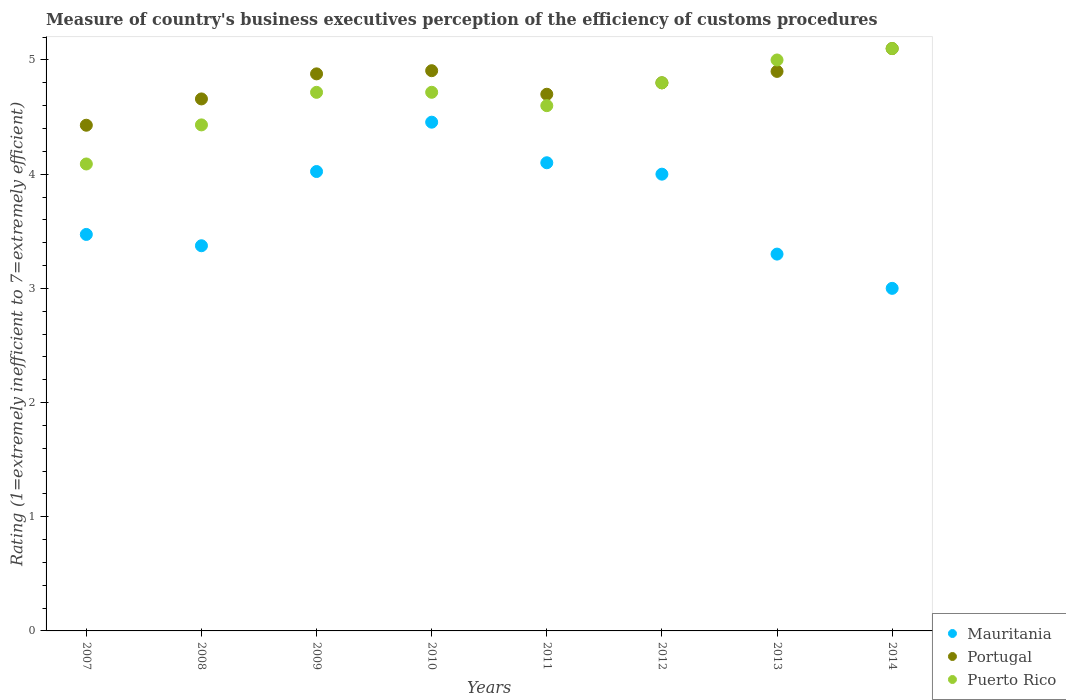How many different coloured dotlines are there?
Keep it short and to the point. 3. Across all years, what is the minimum rating of the efficiency of customs procedure in Mauritania?
Your response must be concise. 3. In which year was the rating of the efficiency of customs procedure in Mauritania minimum?
Your answer should be compact. 2014. What is the total rating of the efficiency of customs procedure in Portugal in the graph?
Provide a succinct answer. 38.37. What is the difference between the rating of the efficiency of customs procedure in Mauritania in 2008 and that in 2013?
Your answer should be very brief. 0.07. What is the difference between the rating of the efficiency of customs procedure in Portugal in 2010 and the rating of the efficiency of customs procedure in Mauritania in 2008?
Provide a succinct answer. 1.53. What is the average rating of the efficiency of customs procedure in Portugal per year?
Give a very brief answer. 4.8. In the year 2012, what is the difference between the rating of the efficiency of customs procedure in Puerto Rico and rating of the efficiency of customs procedure in Mauritania?
Offer a very short reply. 0.8. What is the ratio of the rating of the efficiency of customs procedure in Puerto Rico in 2007 to that in 2010?
Ensure brevity in your answer.  0.87. Is the difference between the rating of the efficiency of customs procedure in Puerto Rico in 2012 and 2013 greater than the difference between the rating of the efficiency of customs procedure in Mauritania in 2012 and 2013?
Provide a short and direct response. No. What is the difference between the highest and the second highest rating of the efficiency of customs procedure in Puerto Rico?
Offer a terse response. 0.1. What is the difference between the highest and the lowest rating of the efficiency of customs procedure in Mauritania?
Your answer should be very brief. 1.46. Is the sum of the rating of the efficiency of customs procedure in Portugal in 2008 and 2009 greater than the maximum rating of the efficiency of customs procedure in Puerto Rico across all years?
Keep it short and to the point. Yes. Is it the case that in every year, the sum of the rating of the efficiency of customs procedure in Portugal and rating of the efficiency of customs procedure in Puerto Rico  is greater than the rating of the efficiency of customs procedure in Mauritania?
Offer a terse response. Yes. Is the rating of the efficiency of customs procedure in Puerto Rico strictly less than the rating of the efficiency of customs procedure in Mauritania over the years?
Provide a short and direct response. No. How many dotlines are there?
Offer a very short reply. 3. What is the difference between two consecutive major ticks on the Y-axis?
Provide a short and direct response. 1. Are the values on the major ticks of Y-axis written in scientific E-notation?
Provide a succinct answer. No. How many legend labels are there?
Provide a succinct answer. 3. How are the legend labels stacked?
Provide a succinct answer. Vertical. What is the title of the graph?
Provide a succinct answer. Measure of country's business executives perception of the efficiency of customs procedures. What is the label or title of the Y-axis?
Keep it short and to the point. Rating (1=extremely inefficient to 7=extremely efficient). What is the Rating (1=extremely inefficient to 7=extremely efficient) of Mauritania in 2007?
Your answer should be very brief. 3.47. What is the Rating (1=extremely inefficient to 7=extremely efficient) in Portugal in 2007?
Offer a terse response. 4.43. What is the Rating (1=extremely inefficient to 7=extremely efficient) in Puerto Rico in 2007?
Provide a succinct answer. 4.09. What is the Rating (1=extremely inefficient to 7=extremely efficient) of Mauritania in 2008?
Give a very brief answer. 3.37. What is the Rating (1=extremely inefficient to 7=extremely efficient) of Portugal in 2008?
Give a very brief answer. 4.66. What is the Rating (1=extremely inefficient to 7=extremely efficient) in Puerto Rico in 2008?
Offer a very short reply. 4.43. What is the Rating (1=extremely inefficient to 7=extremely efficient) in Mauritania in 2009?
Your answer should be very brief. 4.02. What is the Rating (1=extremely inefficient to 7=extremely efficient) of Portugal in 2009?
Your response must be concise. 4.88. What is the Rating (1=extremely inefficient to 7=extremely efficient) in Puerto Rico in 2009?
Your response must be concise. 4.72. What is the Rating (1=extremely inefficient to 7=extremely efficient) in Mauritania in 2010?
Provide a succinct answer. 4.46. What is the Rating (1=extremely inefficient to 7=extremely efficient) in Portugal in 2010?
Give a very brief answer. 4.91. What is the Rating (1=extremely inefficient to 7=extremely efficient) in Puerto Rico in 2010?
Your response must be concise. 4.72. What is the Rating (1=extremely inefficient to 7=extremely efficient) in Puerto Rico in 2011?
Your response must be concise. 4.6. What is the Rating (1=extremely inefficient to 7=extremely efficient) of Portugal in 2012?
Ensure brevity in your answer.  4.8. What is the Rating (1=extremely inefficient to 7=extremely efficient) of Portugal in 2013?
Offer a terse response. 4.9. What is the Rating (1=extremely inefficient to 7=extremely efficient) of Mauritania in 2014?
Provide a succinct answer. 3. What is the Rating (1=extremely inefficient to 7=extremely efficient) of Portugal in 2014?
Your answer should be very brief. 5.1. What is the Rating (1=extremely inefficient to 7=extremely efficient) of Puerto Rico in 2014?
Make the answer very short. 5.1. Across all years, what is the maximum Rating (1=extremely inefficient to 7=extremely efficient) of Mauritania?
Ensure brevity in your answer.  4.46. Across all years, what is the maximum Rating (1=extremely inefficient to 7=extremely efficient) of Portugal?
Provide a short and direct response. 5.1. Across all years, what is the maximum Rating (1=extremely inefficient to 7=extremely efficient) of Puerto Rico?
Your response must be concise. 5.1. Across all years, what is the minimum Rating (1=extremely inefficient to 7=extremely efficient) in Mauritania?
Give a very brief answer. 3. Across all years, what is the minimum Rating (1=extremely inefficient to 7=extremely efficient) in Portugal?
Offer a terse response. 4.43. Across all years, what is the minimum Rating (1=extremely inefficient to 7=extremely efficient) of Puerto Rico?
Keep it short and to the point. 4.09. What is the total Rating (1=extremely inefficient to 7=extremely efficient) in Mauritania in the graph?
Make the answer very short. 29.72. What is the total Rating (1=extremely inefficient to 7=extremely efficient) in Portugal in the graph?
Give a very brief answer. 38.37. What is the total Rating (1=extremely inefficient to 7=extremely efficient) of Puerto Rico in the graph?
Offer a terse response. 37.45. What is the difference between the Rating (1=extremely inefficient to 7=extremely efficient) in Mauritania in 2007 and that in 2008?
Your answer should be compact. 0.1. What is the difference between the Rating (1=extremely inefficient to 7=extremely efficient) in Portugal in 2007 and that in 2008?
Ensure brevity in your answer.  -0.23. What is the difference between the Rating (1=extremely inefficient to 7=extremely efficient) of Puerto Rico in 2007 and that in 2008?
Offer a terse response. -0.34. What is the difference between the Rating (1=extremely inefficient to 7=extremely efficient) in Mauritania in 2007 and that in 2009?
Give a very brief answer. -0.55. What is the difference between the Rating (1=extremely inefficient to 7=extremely efficient) in Portugal in 2007 and that in 2009?
Offer a terse response. -0.45. What is the difference between the Rating (1=extremely inefficient to 7=extremely efficient) in Puerto Rico in 2007 and that in 2009?
Offer a very short reply. -0.63. What is the difference between the Rating (1=extremely inefficient to 7=extremely efficient) in Mauritania in 2007 and that in 2010?
Your response must be concise. -0.98. What is the difference between the Rating (1=extremely inefficient to 7=extremely efficient) of Portugal in 2007 and that in 2010?
Ensure brevity in your answer.  -0.48. What is the difference between the Rating (1=extremely inefficient to 7=extremely efficient) in Puerto Rico in 2007 and that in 2010?
Your answer should be very brief. -0.63. What is the difference between the Rating (1=extremely inefficient to 7=extremely efficient) of Mauritania in 2007 and that in 2011?
Make the answer very short. -0.63. What is the difference between the Rating (1=extremely inefficient to 7=extremely efficient) of Portugal in 2007 and that in 2011?
Provide a short and direct response. -0.27. What is the difference between the Rating (1=extremely inefficient to 7=extremely efficient) of Puerto Rico in 2007 and that in 2011?
Provide a short and direct response. -0.51. What is the difference between the Rating (1=extremely inefficient to 7=extremely efficient) in Mauritania in 2007 and that in 2012?
Your response must be concise. -0.53. What is the difference between the Rating (1=extremely inefficient to 7=extremely efficient) in Portugal in 2007 and that in 2012?
Your response must be concise. -0.37. What is the difference between the Rating (1=extremely inefficient to 7=extremely efficient) in Puerto Rico in 2007 and that in 2012?
Make the answer very short. -0.71. What is the difference between the Rating (1=extremely inefficient to 7=extremely efficient) of Mauritania in 2007 and that in 2013?
Your answer should be compact. 0.17. What is the difference between the Rating (1=extremely inefficient to 7=extremely efficient) of Portugal in 2007 and that in 2013?
Ensure brevity in your answer.  -0.47. What is the difference between the Rating (1=extremely inefficient to 7=extremely efficient) of Puerto Rico in 2007 and that in 2013?
Offer a terse response. -0.91. What is the difference between the Rating (1=extremely inefficient to 7=extremely efficient) of Mauritania in 2007 and that in 2014?
Offer a terse response. 0.47. What is the difference between the Rating (1=extremely inefficient to 7=extremely efficient) of Portugal in 2007 and that in 2014?
Offer a very short reply. -0.67. What is the difference between the Rating (1=extremely inefficient to 7=extremely efficient) of Puerto Rico in 2007 and that in 2014?
Provide a short and direct response. -1.01. What is the difference between the Rating (1=extremely inefficient to 7=extremely efficient) of Mauritania in 2008 and that in 2009?
Your answer should be compact. -0.65. What is the difference between the Rating (1=extremely inefficient to 7=extremely efficient) in Portugal in 2008 and that in 2009?
Offer a very short reply. -0.22. What is the difference between the Rating (1=extremely inefficient to 7=extremely efficient) of Puerto Rico in 2008 and that in 2009?
Give a very brief answer. -0.29. What is the difference between the Rating (1=extremely inefficient to 7=extremely efficient) in Mauritania in 2008 and that in 2010?
Keep it short and to the point. -1.08. What is the difference between the Rating (1=extremely inefficient to 7=extremely efficient) in Portugal in 2008 and that in 2010?
Give a very brief answer. -0.25. What is the difference between the Rating (1=extremely inefficient to 7=extremely efficient) of Puerto Rico in 2008 and that in 2010?
Keep it short and to the point. -0.29. What is the difference between the Rating (1=extremely inefficient to 7=extremely efficient) of Mauritania in 2008 and that in 2011?
Keep it short and to the point. -0.73. What is the difference between the Rating (1=extremely inefficient to 7=extremely efficient) in Portugal in 2008 and that in 2011?
Provide a succinct answer. -0.04. What is the difference between the Rating (1=extremely inefficient to 7=extremely efficient) in Puerto Rico in 2008 and that in 2011?
Ensure brevity in your answer.  -0.17. What is the difference between the Rating (1=extremely inefficient to 7=extremely efficient) of Mauritania in 2008 and that in 2012?
Provide a succinct answer. -0.63. What is the difference between the Rating (1=extremely inefficient to 7=extremely efficient) in Portugal in 2008 and that in 2012?
Give a very brief answer. -0.14. What is the difference between the Rating (1=extremely inefficient to 7=extremely efficient) of Puerto Rico in 2008 and that in 2012?
Offer a terse response. -0.37. What is the difference between the Rating (1=extremely inefficient to 7=extremely efficient) in Mauritania in 2008 and that in 2013?
Offer a very short reply. 0.07. What is the difference between the Rating (1=extremely inefficient to 7=extremely efficient) in Portugal in 2008 and that in 2013?
Your answer should be very brief. -0.24. What is the difference between the Rating (1=extremely inefficient to 7=extremely efficient) in Puerto Rico in 2008 and that in 2013?
Your response must be concise. -0.57. What is the difference between the Rating (1=extremely inefficient to 7=extremely efficient) in Mauritania in 2008 and that in 2014?
Give a very brief answer. 0.37. What is the difference between the Rating (1=extremely inefficient to 7=extremely efficient) in Portugal in 2008 and that in 2014?
Provide a short and direct response. -0.44. What is the difference between the Rating (1=extremely inefficient to 7=extremely efficient) in Puerto Rico in 2008 and that in 2014?
Provide a succinct answer. -0.67. What is the difference between the Rating (1=extremely inefficient to 7=extremely efficient) of Mauritania in 2009 and that in 2010?
Offer a very short reply. -0.43. What is the difference between the Rating (1=extremely inefficient to 7=extremely efficient) in Portugal in 2009 and that in 2010?
Offer a very short reply. -0.03. What is the difference between the Rating (1=extremely inefficient to 7=extremely efficient) in Puerto Rico in 2009 and that in 2010?
Make the answer very short. -0. What is the difference between the Rating (1=extremely inefficient to 7=extremely efficient) of Mauritania in 2009 and that in 2011?
Provide a succinct answer. -0.08. What is the difference between the Rating (1=extremely inefficient to 7=extremely efficient) of Portugal in 2009 and that in 2011?
Your answer should be compact. 0.18. What is the difference between the Rating (1=extremely inefficient to 7=extremely efficient) of Puerto Rico in 2009 and that in 2011?
Keep it short and to the point. 0.12. What is the difference between the Rating (1=extremely inefficient to 7=extremely efficient) in Mauritania in 2009 and that in 2012?
Offer a very short reply. 0.02. What is the difference between the Rating (1=extremely inefficient to 7=extremely efficient) in Portugal in 2009 and that in 2012?
Your answer should be compact. 0.08. What is the difference between the Rating (1=extremely inefficient to 7=extremely efficient) in Puerto Rico in 2009 and that in 2012?
Your response must be concise. -0.08. What is the difference between the Rating (1=extremely inefficient to 7=extremely efficient) in Mauritania in 2009 and that in 2013?
Keep it short and to the point. 0.72. What is the difference between the Rating (1=extremely inefficient to 7=extremely efficient) in Portugal in 2009 and that in 2013?
Your response must be concise. -0.02. What is the difference between the Rating (1=extremely inefficient to 7=extremely efficient) of Puerto Rico in 2009 and that in 2013?
Your answer should be compact. -0.28. What is the difference between the Rating (1=extremely inefficient to 7=extremely efficient) in Mauritania in 2009 and that in 2014?
Provide a short and direct response. 1.02. What is the difference between the Rating (1=extremely inefficient to 7=extremely efficient) of Portugal in 2009 and that in 2014?
Make the answer very short. -0.22. What is the difference between the Rating (1=extremely inefficient to 7=extremely efficient) in Puerto Rico in 2009 and that in 2014?
Keep it short and to the point. -0.38. What is the difference between the Rating (1=extremely inefficient to 7=extremely efficient) in Mauritania in 2010 and that in 2011?
Provide a succinct answer. 0.36. What is the difference between the Rating (1=extremely inefficient to 7=extremely efficient) in Portugal in 2010 and that in 2011?
Your answer should be very brief. 0.21. What is the difference between the Rating (1=extremely inefficient to 7=extremely efficient) of Puerto Rico in 2010 and that in 2011?
Offer a terse response. 0.12. What is the difference between the Rating (1=extremely inefficient to 7=extremely efficient) of Mauritania in 2010 and that in 2012?
Provide a succinct answer. 0.46. What is the difference between the Rating (1=extremely inefficient to 7=extremely efficient) in Portugal in 2010 and that in 2012?
Provide a succinct answer. 0.11. What is the difference between the Rating (1=extremely inefficient to 7=extremely efficient) in Puerto Rico in 2010 and that in 2012?
Offer a very short reply. -0.08. What is the difference between the Rating (1=extremely inefficient to 7=extremely efficient) in Mauritania in 2010 and that in 2013?
Your answer should be very brief. 1.16. What is the difference between the Rating (1=extremely inefficient to 7=extremely efficient) of Portugal in 2010 and that in 2013?
Your answer should be very brief. 0.01. What is the difference between the Rating (1=extremely inefficient to 7=extremely efficient) in Puerto Rico in 2010 and that in 2013?
Your answer should be compact. -0.28. What is the difference between the Rating (1=extremely inefficient to 7=extremely efficient) in Mauritania in 2010 and that in 2014?
Give a very brief answer. 1.46. What is the difference between the Rating (1=extremely inefficient to 7=extremely efficient) of Portugal in 2010 and that in 2014?
Ensure brevity in your answer.  -0.19. What is the difference between the Rating (1=extremely inefficient to 7=extremely efficient) of Puerto Rico in 2010 and that in 2014?
Ensure brevity in your answer.  -0.38. What is the difference between the Rating (1=extremely inefficient to 7=extremely efficient) in Mauritania in 2011 and that in 2012?
Your answer should be compact. 0.1. What is the difference between the Rating (1=extremely inefficient to 7=extremely efficient) in Portugal in 2011 and that in 2012?
Your answer should be compact. -0.1. What is the difference between the Rating (1=extremely inefficient to 7=extremely efficient) in Mauritania in 2011 and that in 2013?
Provide a short and direct response. 0.8. What is the difference between the Rating (1=extremely inefficient to 7=extremely efficient) of Mauritania in 2011 and that in 2014?
Keep it short and to the point. 1.1. What is the difference between the Rating (1=extremely inefficient to 7=extremely efficient) in Portugal in 2012 and that in 2013?
Give a very brief answer. -0.1. What is the difference between the Rating (1=extremely inefficient to 7=extremely efficient) in Puerto Rico in 2012 and that in 2013?
Offer a very short reply. -0.2. What is the difference between the Rating (1=extremely inefficient to 7=extremely efficient) in Mauritania in 2013 and that in 2014?
Ensure brevity in your answer.  0.3. What is the difference between the Rating (1=extremely inefficient to 7=extremely efficient) of Portugal in 2013 and that in 2014?
Your answer should be very brief. -0.2. What is the difference between the Rating (1=extremely inefficient to 7=extremely efficient) in Mauritania in 2007 and the Rating (1=extremely inefficient to 7=extremely efficient) in Portugal in 2008?
Give a very brief answer. -1.19. What is the difference between the Rating (1=extremely inefficient to 7=extremely efficient) of Mauritania in 2007 and the Rating (1=extremely inefficient to 7=extremely efficient) of Puerto Rico in 2008?
Your answer should be compact. -0.96. What is the difference between the Rating (1=extremely inefficient to 7=extremely efficient) in Portugal in 2007 and the Rating (1=extremely inefficient to 7=extremely efficient) in Puerto Rico in 2008?
Make the answer very short. -0. What is the difference between the Rating (1=extremely inefficient to 7=extremely efficient) in Mauritania in 2007 and the Rating (1=extremely inefficient to 7=extremely efficient) in Portugal in 2009?
Offer a very short reply. -1.41. What is the difference between the Rating (1=extremely inefficient to 7=extremely efficient) in Mauritania in 2007 and the Rating (1=extremely inefficient to 7=extremely efficient) in Puerto Rico in 2009?
Your answer should be compact. -1.24. What is the difference between the Rating (1=extremely inefficient to 7=extremely efficient) of Portugal in 2007 and the Rating (1=extremely inefficient to 7=extremely efficient) of Puerto Rico in 2009?
Make the answer very short. -0.29. What is the difference between the Rating (1=extremely inefficient to 7=extremely efficient) in Mauritania in 2007 and the Rating (1=extremely inefficient to 7=extremely efficient) in Portugal in 2010?
Make the answer very short. -1.43. What is the difference between the Rating (1=extremely inefficient to 7=extremely efficient) in Mauritania in 2007 and the Rating (1=extremely inefficient to 7=extremely efficient) in Puerto Rico in 2010?
Your response must be concise. -1.24. What is the difference between the Rating (1=extremely inefficient to 7=extremely efficient) of Portugal in 2007 and the Rating (1=extremely inefficient to 7=extremely efficient) of Puerto Rico in 2010?
Your response must be concise. -0.29. What is the difference between the Rating (1=extremely inefficient to 7=extremely efficient) of Mauritania in 2007 and the Rating (1=extremely inefficient to 7=extremely efficient) of Portugal in 2011?
Your answer should be compact. -1.23. What is the difference between the Rating (1=extremely inefficient to 7=extremely efficient) of Mauritania in 2007 and the Rating (1=extremely inefficient to 7=extremely efficient) of Puerto Rico in 2011?
Keep it short and to the point. -1.13. What is the difference between the Rating (1=extremely inefficient to 7=extremely efficient) in Portugal in 2007 and the Rating (1=extremely inefficient to 7=extremely efficient) in Puerto Rico in 2011?
Offer a terse response. -0.17. What is the difference between the Rating (1=extremely inefficient to 7=extremely efficient) in Mauritania in 2007 and the Rating (1=extremely inefficient to 7=extremely efficient) in Portugal in 2012?
Offer a very short reply. -1.33. What is the difference between the Rating (1=extremely inefficient to 7=extremely efficient) of Mauritania in 2007 and the Rating (1=extremely inefficient to 7=extremely efficient) of Puerto Rico in 2012?
Keep it short and to the point. -1.33. What is the difference between the Rating (1=extremely inefficient to 7=extremely efficient) in Portugal in 2007 and the Rating (1=extremely inefficient to 7=extremely efficient) in Puerto Rico in 2012?
Offer a terse response. -0.37. What is the difference between the Rating (1=extremely inefficient to 7=extremely efficient) of Mauritania in 2007 and the Rating (1=extremely inefficient to 7=extremely efficient) of Portugal in 2013?
Your answer should be compact. -1.43. What is the difference between the Rating (1=extremely inefficient to 7=extremely efficient) of Mauritania in 2007 and the Rating (1=extremely inefficient to 7=extremely efficient) of Puerto Rico in 2013?
Give a very brief answer. -1.53. What is the difference between the Rating (1=extremely inefficient to 7=extremely efficient) of Portugal in 2007 and the Rating (1=extremely inefficient to 7=extremely efficient) of Puerto Rico in 2013?
Your response must be concise. -0.57. What is the difference between the Rating (1=extremely inefficient to 7=extremely efficient) in Mauritania in 2007 and the Rating (1=extremely inefficient to 7=extremely efficient) in Portugal in 2014?
Offer a very short reply. -1.63. What is the difference between the Rating (1=extremely inefficient to 7=extremely efficient) of Mauritania in 2007 and the Rating (1=extremely inefficient to 7=extremely efficient) of Puerto Rico in 2014?
Provide a succinct answer. -1.63. What is the difference between the Rating (1=extremely inefficient to 7=extremely efficient) in Portugal in 2007 and the Rating (1=extremely inefficient to 7=extremely efficient) in Puerto Rico in 2014?
Offer a very short reply. -0.67. What is the difference between the Rating (1=extremely inefficient to 7=extremely efficient) of Mauritania in 2008 and the Rating (1=extremely inefficient to 7=extremely efficient) of Portugal in 2009?
Offer a terse response. -1.51. What is the difference between the Rating (1=extremely inefficient to 7=extremely efficient) in Mauritania in 2008 and the Rating (1=extremely inefficient to 7=extremely efficient) in Puerto Rico in 2009?
Ensure brevity in your answer.  -1.34. What is the difference between the Rating (1=extremely inefficient to 7=extremely efficient) of Portugal in 2008 and the Rating (1=extremely inefficient to 7=extremely efficient) of Puerto Rico in 2009?
Offer a terse response. -0.06. What is the difference between the Rating (1=extremely inefficient to 7=extremely efficient) in Mauritania in 2008 and the Rating (1=extremely inefficient to 7=extremely efficient) in Portugal in 2010?
Ensure brevity in your answer.  -1.53. What is the difference between the Rating (1=extremely inefficient to 7=extremely efficient) in Mauritania in 2008 and the Rating (1=extremely inefficient to 7=extremely efficient) in Puerto Rico in 2010?
Ensure brevity in your answer.  -1.34. What is the difference between the Rating (1=extremely inefficient to 7=extremely efficient) in Portugal in 2008 and the Rating (1=extremely inefficient to 7=extremely efficient) in Puerto Rico in 2010?
Your response must be concise. -0.06. What is the difference between the Rating (1=extremely inefficient to 7=extremely efficient) of Mauritania in 2008 and the Rating (1=extremely inefficient to 7=extremely efficient) of Portugal in 2011?
Give a very brief answer. -1.33. What is the difference between the Rating (1=extremely inefficient to 7=extremely efficient) in Mauritania in 2008 and the Rating (1=extremely inefficient to 7=extremely efficient) in Puerto Rico in 2011?
Make the answer very short. -1.23. What is the difference between the Rating (1=extremely inefficient to 7=extremely efficient) in Portugal in 2008 and the Rating (1=extremely inefficient to 7=extremely efficient) in Puerto Rico in 2011?
Provide a succinct answer. 0.06. What is the difference between the Rating (1=extremely inefficient to 7=extremely efficient) in Mauritania in 2008 and the Rating (1=extremely inefficient to 7=extremely efficient) in Portugal in 2012?
Offer a terse response. -1.43. What is the difference between the Rating (1=extremely inefficient to 7=extremely efficient) in Mauritania in 2008 and the Rating (1=extremely inefficient to 7=extremely efficient) in Puerto Rico in 2012?
Make the answer very short. -1.43. What is the difference between the Rating (1=extremely inefficient to 7=extremely efficient) of Portugal in 2008 and the Rating (1=extremely inefficient to 7=extremely efficient) of Puerto Rico in 2012?
Provide a succinct answer. -0.14. What is the difference between the Rating (1=extremely inefficient to 7=extremely efficient) in Mauritania in 2008 and the Rating (1=extremely inefficient to 7=extremely efficient) in Portugal in 2013?
Offer a terse response. -1.53. What is the difference between the Rating (1=extremely inefficient to 7=extremely efficient) of Mauritania in 2008 and the Rating (1=extremely inefficient to 7=extremely efficient) of Puerto Rico in 2013?
Make the answer very short. -1.63. What is the difference between the Rating (1=extremely inefficient to 7=extremely efficient) in Portugal in 2008 and the Rating (1=extremely inefficient to 7=extremely efficient) in Puerto Rico in 2013?
Your answer should be compact. -0.34. What is the difference between the Rating (1=extremely inefficient to 7=extremely efficient) in Mauritania in 2008 and the Rating (1=extremely inefficient to 7=extremely efficient) in Portugal in 2014?
Offer a very short reply. -1.73. What is the difference between the Rating (1=extremely inefficient to 7=extremely efficient) in Mauritania in 2008 and the Rating (1=extremely inefficient to 7=extremely efficient) in Puerto Rico in 2014?
Your answer should be compact. -1.73. What is the difference between the Rating (1=extremely inefficient to 7=extremely efficient) in Portugal in 2008 and the Rating (1=extremely inefficient to 7=extremely efficient) in Puerto Rico in 2014?
Make the answer very short. -0.44. What is the difference between the Rating (1=extremely inefficient to 7=extremely efficient) of Mauritania in 2009 and the Rating (1=extremely inefficient to 7=extremely efficient) of Portugal in 2010?
Offer a terse response. -0.88. What is the difference between the Rating (1=extremely inefficient to 7=extremely efficient) of Mauritania in 2009 and the Rating (1=extremely inefficient to 7=extremely efficient) of Puerto Rico in 2010?
Offer a terse response. -0.69. What is the difference between the Rating (1=extremely inefficient to 7=extremely efficient) in Portugal in 2009 and the Rating (1=extremely inefficient to 7=extremely efficient) in Puerto Rico in 2010?
Offer a terse response. 0.16. What is the difference between the Rating (1=extremely inefficient to 7=extremely efficient) of Mauritania in 2009 and the Rating (1=extremely inefficient to 7=extremely efficient) of Portugal in 2011?
Provide a succinct answer. -0.68. What is the difference between the Rating (1=extremely inefficient to 7=extremely efficient) in Mauritania in 2009 and the Rating (1=extremely inefficient to 7=extremely efficient) in Puerto Rico in 2011?
Provide a short and direct response. -0.58. What is the difference between the Rating (1=extremely inefficient to 7=extremely efficient) of Portugal in 2009 and the Rating (1=extremely inefficient to 7=extremely efficient) of Puerto Rico in 2011?
Provide a succinct answer. 0.28. What is the difference between the Rating (1=extremely inefficient to 7=extremely efficient) of Mauritania in 2009 and the Rating (1=extremely inefficient to 7=extremely efficient) of Portugal in 2012?
Offer a very short reply. -0.78. What is the difference between the Rating (1=extremely inefficient to 7=extremely efficient) in Mauritania in 2009 and the Rating (1=extremely inefficient to 7=extremely efficient) in Puerto Rico in 2012?
Ensure brevity in your answer.  -0.78. What is the difference between the Rating (1=extremely inefficient to 7=extremely efficient) in Portugal in 2009 and the Rating (1=extremely inefficient to 7=extremely efficient) in Puerto Rico in 2012?
Keep it short and to the point. 0.08. What is the difference between the Rating (1=extremely inefficient to 7=extremely efficient) in Mauritania in 2009 and the Rating (1=extremely inefficient to 7=extremely efficient) in Portugal in 2013?
Keep it short and to the point. -0.88. What is the difference between the Rating (1=extremely inefficient to 7=extremely efficient) in Mauritania in 2009 and the Rating (1=extremely inefficient to 7=extremely efficient) in Puerto Rico in 2013?
Your answer should be very brief. -0.98. What is the difference between the Rating (1=extremely inefficient to 7=extremely efficient) in Portugal in 2009 and the Rating (1=extremely inefficient to 7=extremely efficient) in Puerto Rico in 2013?
Your answer should be very brief. -0.12. What is the difference between the Rating (1=extremely inefficient to 7=extremely efficient) of Mauritania in 2009 and the Rating (1=extremely inefficient to 7=extremely efficient) of Portugal in 2014?
Offer a terse response. -1.08. What is the difference between the Rating (1=extremely inefficient to 7=extremely efficient) in Mauritania in 2009 and the Rating (1=extremely inefficient to 7=extremely efficient) in Puerto Rico in 2014?
Your answer should be very brief. -1.08. What is the difference between the Rating (1=extremely inefficient to 7=extremely efficient) of Portugal in 2009 and the Rating (1=extremely inefficient to 7=extremely efficient) of Puerto Rico in 2014?
Offer a terse response. -0.22. What is the difference between the Rating (1=extremely inefficient to 7=extremely efficient) in Mauritania in 2010 and the Rating (1=extremely inefficient to 7=extremely efficient) in Portugal in 2011?
Give a very brief answer. -0.24. What is the difference between the Rating (1=extremely inefficient to 7=extremely efficient) in Mauritania in 2010 and the Rating (1=extremely inefficient to 7=extremely efficient) in Puerto Rico in 2011?
Ensure brevity in your answer.  -0.14. What is the difference between the Rating (1=extremely inefficient to 7=extremely efficient) of Portugal in 2010 and the Rating (1=extremely inefficient to 7=extremely efficient) of Puerto Rico in 2011?
Provide a succinct answer. 0.31. What is the difference between the Rating (1=extremely inefficient to 7=extremely efficient) in Mauritania in 2010 and the Rating (1=extremely inefficient to 7=extremely efficient) in Portugal in 2012?
Ensure brevity in your answer.  -0.34. What is the difference between the Rating (1=extremely inefficient to 7=extremely efficient) in Mauritania in 2010 and the Rating (1=extremely inefficient to 7=extremely efficient) in Puerto Rico in 2012?
Your answer should be very brief. -0.34. What is the difference between the Rating (1=extremely inefficient to 7=extremely efficient) in Portugal in 2010 and the Rating (1=extremely inefficient to 7=extremely efficient) in Puerto Rico in 2012?
Your response must be concise. 0.11. What is the difference between the Rating (1=extremely inefficient to 7=extremely efficient) in Mauritania in 2010 and the Rating (1=extremely inefficient to 7=extremely efficient) in Portugal in 2013?
Your response must be concise. -0.44. What is the difference between the Rating (1=extremely inefficient to 7=extremely efficient) of Mauritania in 2010 and the Rating (1=extremely inefficient to 7=extremely efficient) of Puerto Rico in 2013?
Ensure brevity in your answer.  -0.54. What is the difference between the Rating (1=extremely inefficient to 7=extremely efficient) of Portugal in 2010 and the Rating (1=extremely inefficient to 7=extremely efficient) of Puerto Rico in 2013?
Your answer should be very brief. -0.09. What is the difference between the Rating (1=extremely inefficient to 7=extremely efficient) in Mauritania in 2010 and the Rating (1=extremely inefficient to 7=extremely efficient) in Portugal in 2014?
Your answer should be very brief. -0.64. What is the difference between the Rating (1=extremely inefficient to 7=extremely efficient) of Mauritania in 2010 and the Rating (1=extremely inefficient to 7=extremely efficient) of Puerto Rico in 2014?
Offer a terse response. -0.64. What is the difference between the Rating (1=extremely inefficient to 7=extremely efficient) of Portugal in 2010 and the Rating (1=extremely inefficient to 7=extremely efficient) of Puerto Rico in 2014?
Make the answer very short. -0.19. What is the difference between the Rating (1=extremely inefficient to 7=extremely efficient) in Portugal in 2011 and the Rating (1=extremely inefficient to 7=extremely efficient) in Puerto Rico in 2012?
Ensure brevity in your answer.  -0.1. What is the difference between the Rating (1=extremely inefficient to 7=extremely efficient) in Mauritania in 2012 and the Rating (1=extremely inefficient to 7=extremely efficient) in Portugal in 2014?
Your answer should be compact. -1.1. What is the difference between the Rating (1=extremely inefficient to 7=extremely efficient) of Mauritania in 2012 and the Rating (1=extremely inefficient to 7=extremely efficient) of Puerto Rico in 2014?
Ensure brevity in your answer.  -1.1. What is the difference between the Rating (1=extremely inefficient to 7=extremely efficient) of Portugal in 2012 and the Rating (1=extremely inefficient to 7=extremely efficient) of Puerto Rico in 2014?
Offer a terse response. -0.3. What is the average Rating (1=extremely inefficient to 7=extremely efficient) of Mauritania per year?
Your response must be concise. 3.72. What is the average Rating (1=extremely inefficient to 7=extremely efficient) of Portugal per year?
Make the answer very short. 4.8. What is the average Rating (1=extremely inefficient to 7=extremely efficient) in Puerto Rico per year?
Your answer should be very brief. 4.68. In the year 2007, what is the difference between the Rating (1=extremely inefficient to 7=extremely efficient) of Mauritania and Rating (1=extremely inefficient to 7=extremely efficient) of Portugal?
Offer a very short reply. -0.96. In the year 2007, what is the difference between the Rating (1=extremely inefficient to 7=extremely efficient) of Mauritania and Rating (1=extremely inefficient to 7=extremely efficient) of Puerto Rico?
Give a very brief answer. -0.62. In the year 2007, what is the difference between the Rating (1=extremely inefficient to 7=extremely efficient) in Portugal and Rating (1=extremely inefficient to 7=extremely efficient) in Puerto Rico?
Your answer should be very brief. 0.34. In the year 2008, what is the difference between the Rating (1=extremely inefficient to 7=extremely efficient) in Mauritania and Rating (1=extremely inefficient to 7=extremely efficient) in Portugal?
Provide a short and direct response. -1.29. In the year 2008, what is the difference between the Rating (1=extremely inefficient to 7=extremely efficient) of Mauritania and Rating (1=extremely inefficient to 7=extremely efficient) of Puerto Rico?
Your answer should be very brief. -1.06. In the year 2008, what is the difference between the Rating (1=extremely inefficient to 7=extremely efficient) of Portugal and Rating (1=extremely inefficient to 7=extremely efficient) of Puerto Rico?
Provide a succinct answer. 0.23. In the year 2009, what is the difference between the Rating (1=extremely inefficient to 7=extremely efficient) in Mauritania and Rating (1=extremely inefficient to 7=extremely efficient) in Portugal?
Give a very brief answer. -0.86. In the year 2009, what is the difference between the Rating (1=extremely inefficient to 7=extremely efficient) of Mauritania and Rating (1=extremely inefficient to 7=extremely efficient) of Puerto Rico?
Provide a succinct answer. -0.69. In the year 2009, what is the difference between the Rating (1=extremely inefficient to 7=extremely efficient) in Portugal and Rating (1=extremely inefficient to 7=extremely efficient) in Puerto Rico?
Your answer should be very brief. 0.16. In the year 2010, what is the difference between the Rating (1=extremely inefficient to 7=extremely efficient) in Mauritania and Rating (1=extremely inefficient to 7=extremely efficient) in Portugal?
Provide a short and direct response. -0.45. In the year 2010, what is the difference between the Rating (1=extremely inefficient to 7=extremely efficient) in Mauritania and Rating (1=extremely inefficient to 7=extremely efficient) in Puerto Rico?
Offer a terse response. -0.26. In the year 2010, what is the difference between the Rating (1=extremely inefficient to 7=extremely efficient) in Portugal and Rating (1=extremely inefficient to 7=extremely efficient) in Puerto Rico?
Make the answer very short. 0.19. In the year 2012, what is the difference between the Rating (1=extremely inefficient to 7=extremely efficient) in Mauritania and Rating (1=extremely inefficient to 7=extremely efficient) in Portugal?
Keep it short and to the point. -0.8. In the year 2014, what is the difference between the Rating (1=extremely inefficient to 7=extremely efficient) of Mauritania and Rating (1=extremely inefficient to 7=extremely efficient) of Portugal?
Offer a terse response. -2.1. In the year 2014, what is the difference between the Rating (1=extremely inefficient to 7=extremely efficient) in Mauritania and Rating (1=extremely inefficient to 7=extremely efficient) in Puerto Rico?
Give a very brief answer. -2.1. In the year 2014, what is the difference between the Rating (1=extremely inefficient to 7=extremely efficient) of Portugal and Rating (1=extremely inefficient to 7=extremely efficient) of Puerto Rico?
Your answer should be very brief. 0. What is the ratio of the Rating (1=extremely inefficient to 7=extremely efficient) of Mauritania in 2007 to that in 2008?
Make the answer very short. 1.03. What is the ratio of the Rating (1=extremely inefficient to 7=extremely efficient) of Portugal in 2007 to that in 2008?
Your answer should be compact. 0.95. What is the ratio of the Rating (1=extremely inefficient to 7=extremely efficient) of Puerto Rico in 2007 to that in 2008?
Provide a succinct answer. 0.92. What is the ratio of the Rating (1=extremely inefficient to 7=extremely efficient) in Mauritania in 2007 to that in 2009?
Ensure brevity in your answer.  0.86. What is the ratio of the Rating (1=extremely inefficient to 7=extremely efficient) in Portugal in 2007 to that in 2009?
Provide a succinct answer. 0.91. What is the ratio of the Rating (1=extremely inefficient to 7=extremely efficient) of Puerto Rico in 2007 to that in 2009?
Ensure brevity in your answer.  0.87. What is the ratio of the Rating (1=extremely inefficient to 7=extremely efficient) of Mauritania in 2007 to that in 2010?
Ensure brevity in your answer.  0.78. What is the ratio of the Rating (1=extremely inefficient to 7=extremely efficient) in Portugal in 2007 to that in 2010?
Give a very brief answer. 0.9. What is the ratio of the Rating (1=extremely inefficient to 7=extremely efficient) of Puerto Rico in 2007 to that in 2010?
Your response must be concise. 0.87. What is the ratio of the Rating (1=extremely inefficient to 7=extremely efficient) in Mauritania in 2007 to that in 2011?
Provide a short and direct response. 0.85. What is the ratio of the Rating (1=extremely inefficient to 7=extremely efficient) in Portugal in 2007 to that in 2011?
Offer a terse response. 0.94. What is the ratio of the Rating (1=extremely inefficient to 7=extremely efficient) of Puerto Rico in 2007 to that in 2011?
Your answer should be compact. 0.89. What is the ratio of the Rating (1=extremely inefficient to 7=extremely efficient) of Mauritania in 2007 to that in 2012?
Make the answer very short. 0.87. What is the ratio of the Rating (1=extremely inefficient to 7=extremely efficient) of Portugal in 2007 to that in 2012?
Your answer should be very brief. 0.92. What is the ratio of the Rating (1=extremely inefficient to 7=extremely efficient) in Puerto Rico in 2007 to that in 2012?
Offer a very short reply. 0.85. What is the ratio of the Rating (1=extremely inefficient to 7=extremely efficient) in Mauritania in 2007 to that in 2013?
Provide a succinct answer. 1.05. What is the ratio of the Rating (1=extremely inefficient to 7=extremely efficient) of Portugal in 2007 to that in 2013?
Offer a very short reply. 0.9. What is the ratio of the Rating (1=extremely inefficient to 7=extremely efficient) in Puerto Rico in 2007 to that in 2013?
Ensure brevity in your answer.  0.82. What is the ratio of the Rating (1=extremely inefficient to 7=extremely efficient) of Mauritania in 2007 to that in 2014?
Make the answer very short. 1.16. What is the ratio of the Rating (1=extremely inefficient to 7=extremely efficient) in Portugal in 2007 to that in 2014?
Your answer should be compact. 0.87. What is the ratio of the Rating (1=extremely inefficient to 7=extremely efficient) of Puerto Rico in 2007 to that in 2014?
Provide a short and direct response. 0.8. What is the ratio of the Rating (1=extremely inefficient to 7=extremely efficient) of Mauritania in 2008 to that in 2009?
Your answer should be compact. 0.84. What is the ratio of the Rating (1=extremely inefficient to 7=extremely efficient) of Portugal in 2008 to that in 2009?
Your answer should be compact. 0.95. What is the ratio of the Rating (1=extremely inefficient to 7=extremely efficient) of Puerto Rico in 2008 to that in 2009?
Provide a short and direct response. 0.94. What is the ratio of the Rating (1=extremely inefficient to 7=extremely efficient) of Mauritania in 2008 to that in 2010?
Offer a terse response. 0.76. What is the ratio of the Rating (1=extremely inefficient to 7=extremely efficient) of Portugal in 2008 to that in 2010?
Provide a succinct answer. 0.95. What is the ratio of the Rating (1=extremely inefficient to 7=extremely efficient) of Puerto Rico in 2008 to that in 2010?
Your response must be concise. 0.94. What is the ratio of the Rating (1=extremely inefficient to 7=extremely efficient) in Mauritania in 2008 to that in 2011?
Your answer should be compact. 0.82. What is the ratio of the Rating (1=extremely inefficient to 7=extremely efficient) of Puerto Rico in 2008 to that in 2011?
Your response must be concise. 0.96. What is the ratio of the Rating (1=extremely inefficient to 7=extremely efficient) of Mauritania in 2008 to that in 2012?
Make the answer very short. 0.84. What is the ratio of the Rating (1=extremely inefficient to 7=extremely efficient) in Portugal in 2008 to that in 2012?
Ensure brevity in your answer.  0.97. What is the ratio of the Rating (1=extremely inefficient to 7=extremely efficient) in Puerto Rico in 2008 to that in 2012?
Make the answer very short. 0.92. What is the ratio of the Rating (1=extremely inefficient to 7=extremely efficient) of Mauritania in 2008 to that in 2013?
Make the answer very short. 1.02. What is the ratio of the Rating (1=extremely inefficient to 7=extremely efficient) in Portugal in 2008 to that in 2013?
Keep it short and to the point. 0.95. What is the ratio of the Rating (1=extremely inefficient to 7=extremely efficient) in Puerto Rico in 2008 to that in 2013?
Your answer should be very brief. 0.89. What is the ratio of the Rating (1=extremely inefficient to 7=extremely efficient) in Mauritania in 2008 to that in 2014?
Keep it short and to the point. 1.12. What is the ratio of the Rating (1=extremely inefficient to 7=extremely efficient) in Portugal in 2008 to that in 2014?
Your response must be concise. 0.91. What is the ratio of the Rating (1=extremely inefficient to 7=extremely efficient) of Puerto Rico in 2008 to that in 2014?
Provide a short and direct response. 0.87. What is the ratio of the Rating (1=extremely inefficient to 7=extremely efficient) of Mauritania in 2009 to that in 2010?
Offer a terse response. 0.9. What is the ratio of the Rating (1=extremely inefficient to 7=extremely efficient) in Portugal in 2009 to that in 2010?
Give a very brief answer. 0.99. What is the ratio of the Rating (1=extremely inefficient to 7=extremely efficient) of Puerto Rico in 2009 to that in 2010?
Offer a very short reply. 1. What is the ratio of the Rating (1=extremely inefficient to 7=extremely efficient) of Mauritania in 2009 to that in 2011?
Your answer should be compact. 0.98. What is the ratio of the Rating (1=extremely inefficient to 7=extremely efficient) in Portugal in 2009 to that in 2011?
Provide a short and direct response. 1.04. What is the ratio of the Rating (1=extremely inefficient to 7=extremely efficient) in Puerto Rico in 2009 to that in 2011?
Your response must be concise. 1.03. What is the ratio of the Rating (1=extremely inefficient to 7=extremely efficient) in Mauritania in 2009 to that in 2012?
Your answer should be very brief. 1.01. What is the ratio of the Rating (1=extremely inefficient to 7=extremely efficient) in Portugal in 2009 to that in 2012?
Your answer should be very brief. 1.02. What is the ratio of the Rating (1=extremely inefficient to 7=extremely efficient) in Puerto Rico in 2009 to that in 2012?
Keep it short and to the point. 0.98. What is the ratio of the Rating (1=extremely inefficient to 7=extremely efficient) in Mauritania in 2009 to that in 2013?
Offer a very short reply. 1.22. What is the ratio of the Rating (1=extremely inefficient to 7=extremely efficient) of Puerto Rico in 2009 to that in 2013?
Offer a terse response. 0.94. What is the ratio of the Rating (1=extremely inefficient to 7=extremely efficient) in Mauritania in 2009 to that in 2014?
Make the answer very short. 1.34. What is the ratio of the Rating (1=extremely inefficient to 7=extremely efficient) in Portugal in 2009 to that in 2014?
Offer a terse response. 0.96. What is the ratio of the Rating (1=extremely inefficient to 7=extremely efficient) in Puerto Rico in 2009 to that in 2014?
Keep it short and to the point. 0.92. What is the ratio of the Rating (1=extremely inefficient to 7=extremely efficient) in Mauritania in 2010 to that in 2011?
Give a very brief answer. 1.09. What is the ratio of the Rating (1=extremely inefficient to 7=extremely efficient) of Portugal in 2010 to that in 2011?
Your answer should be compact. 1.04. What is the ratio of the Rating (1=extremely inefficient to 7=extremely efficient) of Puerto Rico in 2010 to that in 2011?
Keep it short and to the point. 1.03. What is the ratio of the Rating (1=extremely inefficient to 7=extremely efficient) in Mauritania in 2010 to that in 2012?
Provide a succinct answer. 1.11. What is the ratio of the Rating (1=extremely inefficient to 7=extremely efficient) in Portugal in 2010 to that in 2012?
Keep it short and to the point. 1.02. What is the ratio of the Rating (1=extremely inefficient to 7=extremely efficient) in Puerto Rico in 2010 to that in 2012?
Make the answer very short. 0.98. What is the ratio of the Rating (1=extremely inefficient to 7=extremely efficient) of Mauritania in 2010 to that in 2013?
Keep it short and to the point. 1.35. What is the ratio of the Rating (1=extremely inefficient to 7=extremely efficient) in Puerto Rico in 2010 to that in 2013?
Make the answer very short. 0.94. What is the ratio of the Rating (1=extremely inefficient to 7=extremely efficient) of Mauritania in 2010 to that in 2014?
Ensure brevity in your answer.  1.49. What is the ratio of the Rating (1=extremely inefficient to 7=extremely efficient) in Portugal in 2010 to that in 2014?
Give a very brief answer. 0.96. What is the ratio of the Rating (1=extremely inefficient to 7=extremely efficient) in Puerto Rico in 2010 to that in 2014?
Your answer should be very brief. 0.92. What is the ratio of the Rating (1=extremely inefficient to 7=extremely efficient) of Portugal in 2011 to that in 2012?
Offer a very short reply. 0.98. What is the ratio of the Rating (1=extremely inefficient to 7=extremely efficient) in Puerto Rico in 2011 to that in 2012?
Make the answer very short. 0.96. What is the ratio of the Rating (1=extremely inefficient to 7=extremely efficient) in Mauritania in 2011 to that in 2013?
Offer a terse response. 1.24. What is the ratio of the Rating (1=extremely inefficient to 7=extremely efficient) of Portugal in 2011 to that in 2013?
Provide a succinct answer. 0.96. What is the ratio of the Rating (1=extremely inefficient to 7=extremely efficient) in Mauritania in 2011 to that in 2014?
Offer a terse response. 1.37. What is the ratio of the Rating (1=extremely inefficient to 7=extremely efficient) in Portugal in 2011 to that in 2014?
Give a very brief answer. 0.92. What is the ratio of the Rating (1=extremely inefficient to 7=extremely efficient) of Puerto Rico in 2011 to that in 2014?
Provide a short and direct response. 0.9. What is the ratio of the Rating (1=extremely inefficient to 7=extremely efficient) in Mauritania in 2012 to that in 2013?
Make the answer very short. 1.21. What is the ratio of the Rating (1=extremely inefficient to 7=extremely efficient) in Portugal in 2012 to that in 2013?
Keep it short and to the point. 0.98. What is the ratio of the Rating (1=extremely inefficient to 7=extremely efficient) in Puerto Rico in 2012 to that in 2013?
Your answer should be very brief. 0.96. What is the ratio of the Rating (1=extremely inefficient to 7=extremely efficient) in Portugal in 2012 to that in 2014?
Offer a terse response. 0.94. What is the ratio of the Rating (1=extremely inefficient to 7=extremely efficient) of Mauritania in 2013 to that in 2014?
Make the answer very short. 1.1. What is the ratio of the Rating (1=extremely inefficient to 7=extremely efficient) of Portugal in 2013 to that in 2014?
Your answer should be very brief. 0.96. What is the ratio of the Rating (1=extremely inefficient to 7=extremely efficient) of Puerto Rico in 2013 to that in 2014?
Ensure brevity in your answer.  0.98. What is the difference between the highest and the second highest Rating (1=extremely inefficient to 7=extremely efficient) of Mauritania?
Offer a terse response. 0.36. What is the difference between the highest and the second highest Rating (1=extremely inefficient to 7=extremely efficient) of Portugal?
Your response must be concise. 0.19. What is the difference between the highest and the lowest Rating (1=extremely inefficient to 7=extremely efficient) in Mauritania?
Provide a succinct answer. 1.46. What is the difference between the highest and the lowest Rating (1=extremely inefficient to 7=extremely efficient) of Portugal?
Ensure brevity in your answer.  0.67. What is the difference between the highest and the lowest Rating (1=extremely inefficient to 7=extremely efficient) in Puerto Rico?
Your answer should be compact. 1.01. 